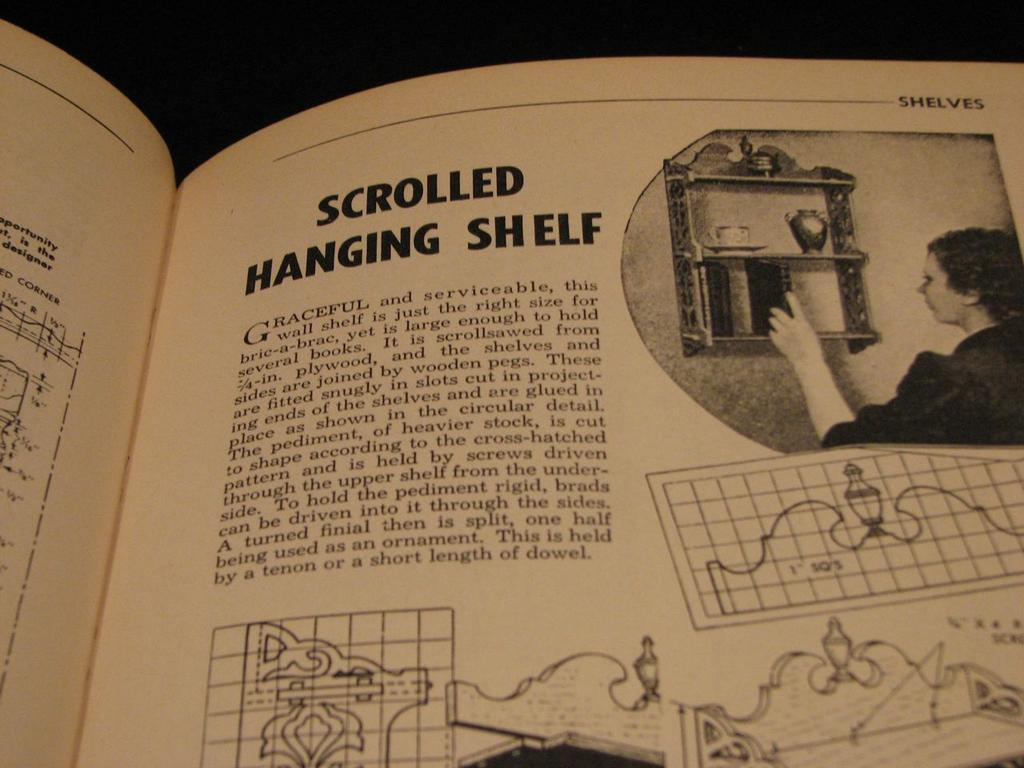What object is present in the image that is related to reading or learning? There is a book in the image. What type of content can be found in the book? The book contains an article. Can you describe the person visible in the image? The image only shows a person, but no specific details about their appearance or actions are provided. What color is the background of the image? The background of the image is black. Is there any dirt visible on the person's shoes in the image? There is no information about the person's shoes or any dirt on them in the image. Can you tell me if the person in the image is a boy? The image only shows a person, but no specific details about their gender are provided. 